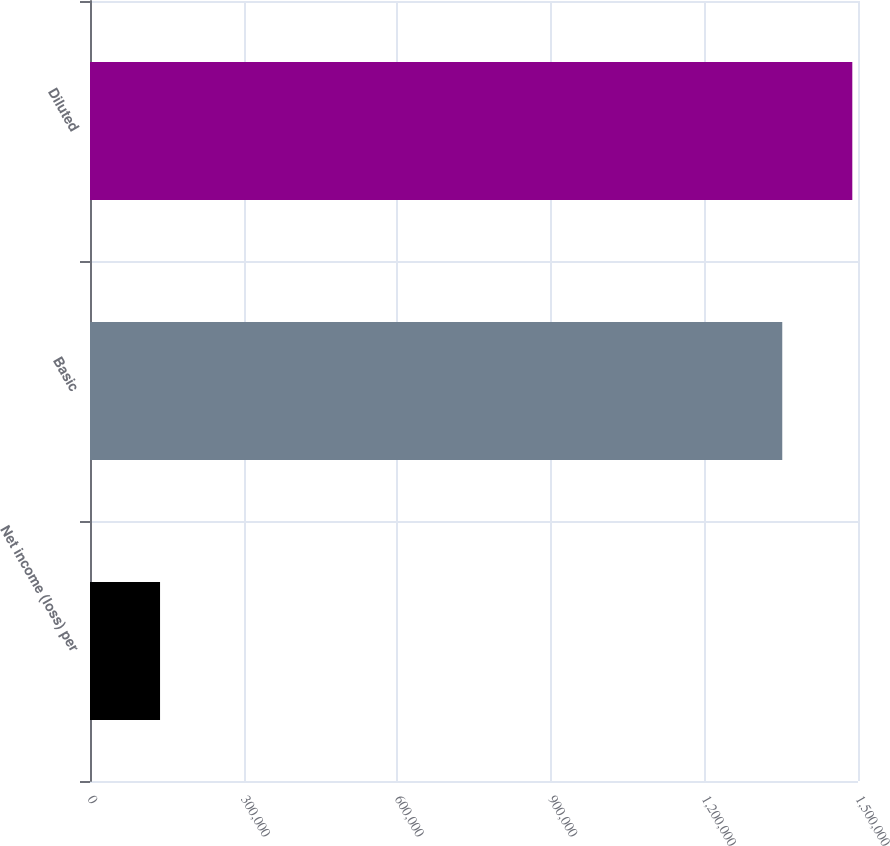Convert chart to OTSL. <chart><loc_0><loc_0><loc_500><loc_500><bar_chart><fcel>Net income (loss) per<fcel>Basic<fcel>Diluted<nl><fcel>136807<fcel>1.35208e+06<fcel>1.48888e+06<nl></chart> 